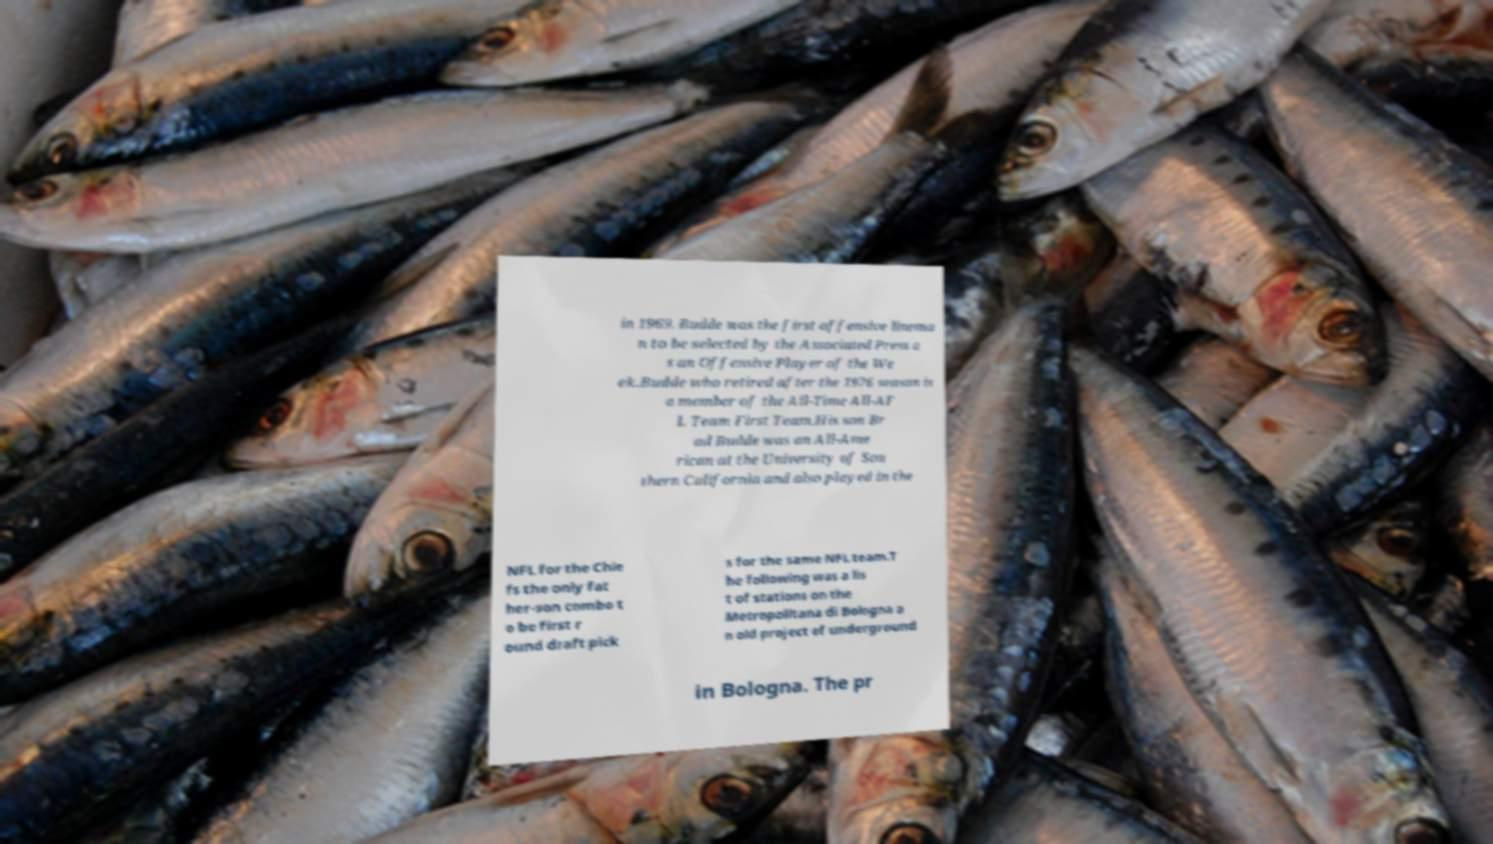There's text embedded in this image that I need extracted. Can you transcribe it verbatim? in 1969. Budde was the first offensive linema n to be selected by the Associated Press a s an Offensive Player of the We ek.Budde who retired after the 1976 season is a member of the All-Time All-AF L Team First Team.His son Br ad Budde was an All-Ame rican at the University of Sou thern California and also played in the NFL for the Chie fs the only fat her-son combo t o be first r ound draft pick s for the same NFL team.T he following was a lis t of stations on the Metropolitana di Bologna a n old project of underground in Bologna. The pr 